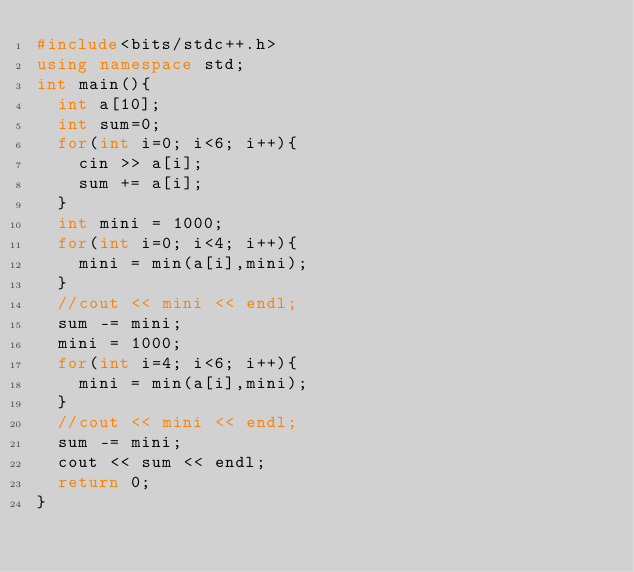<code> <loc_0><loc_0><loc_500><loc_500><_C++_>#include<bits/stdc++.h>
using namespace std;
int main(){
  int a[10];
  int sum=0;
  for(int i=0; i<6; i++){
    cin >> a[i];
    sum += a[i];
  }
  int mini = 1000;
  for(int i=0; i<4; i++){
    mini = min(a[i],mini);
  }
  //cout << mini << endl;
  sum -= mini;
  mini = 1000;
  for(int i=4; i<6; i++){
    mini = min(a[i],mini);
  }
  //cout << mini << endl;
  sum -= mini;
  cout << sum << endl;
  return 0;
}

</code> 